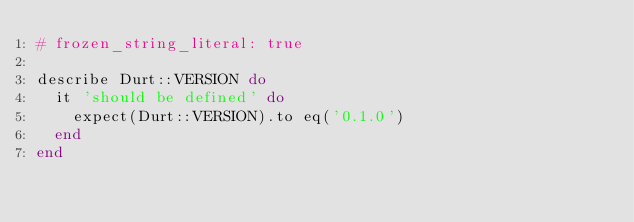Convert code to text. <code><loc_0><loc_0><loc_500><loc_500><_Ruby_># frozen_string_literal: true

describe Durt::VERSION do
  it 'should be defined' do
    expect(Durt::VERSION).to eq('0.1.0')
  end
end
</code> 